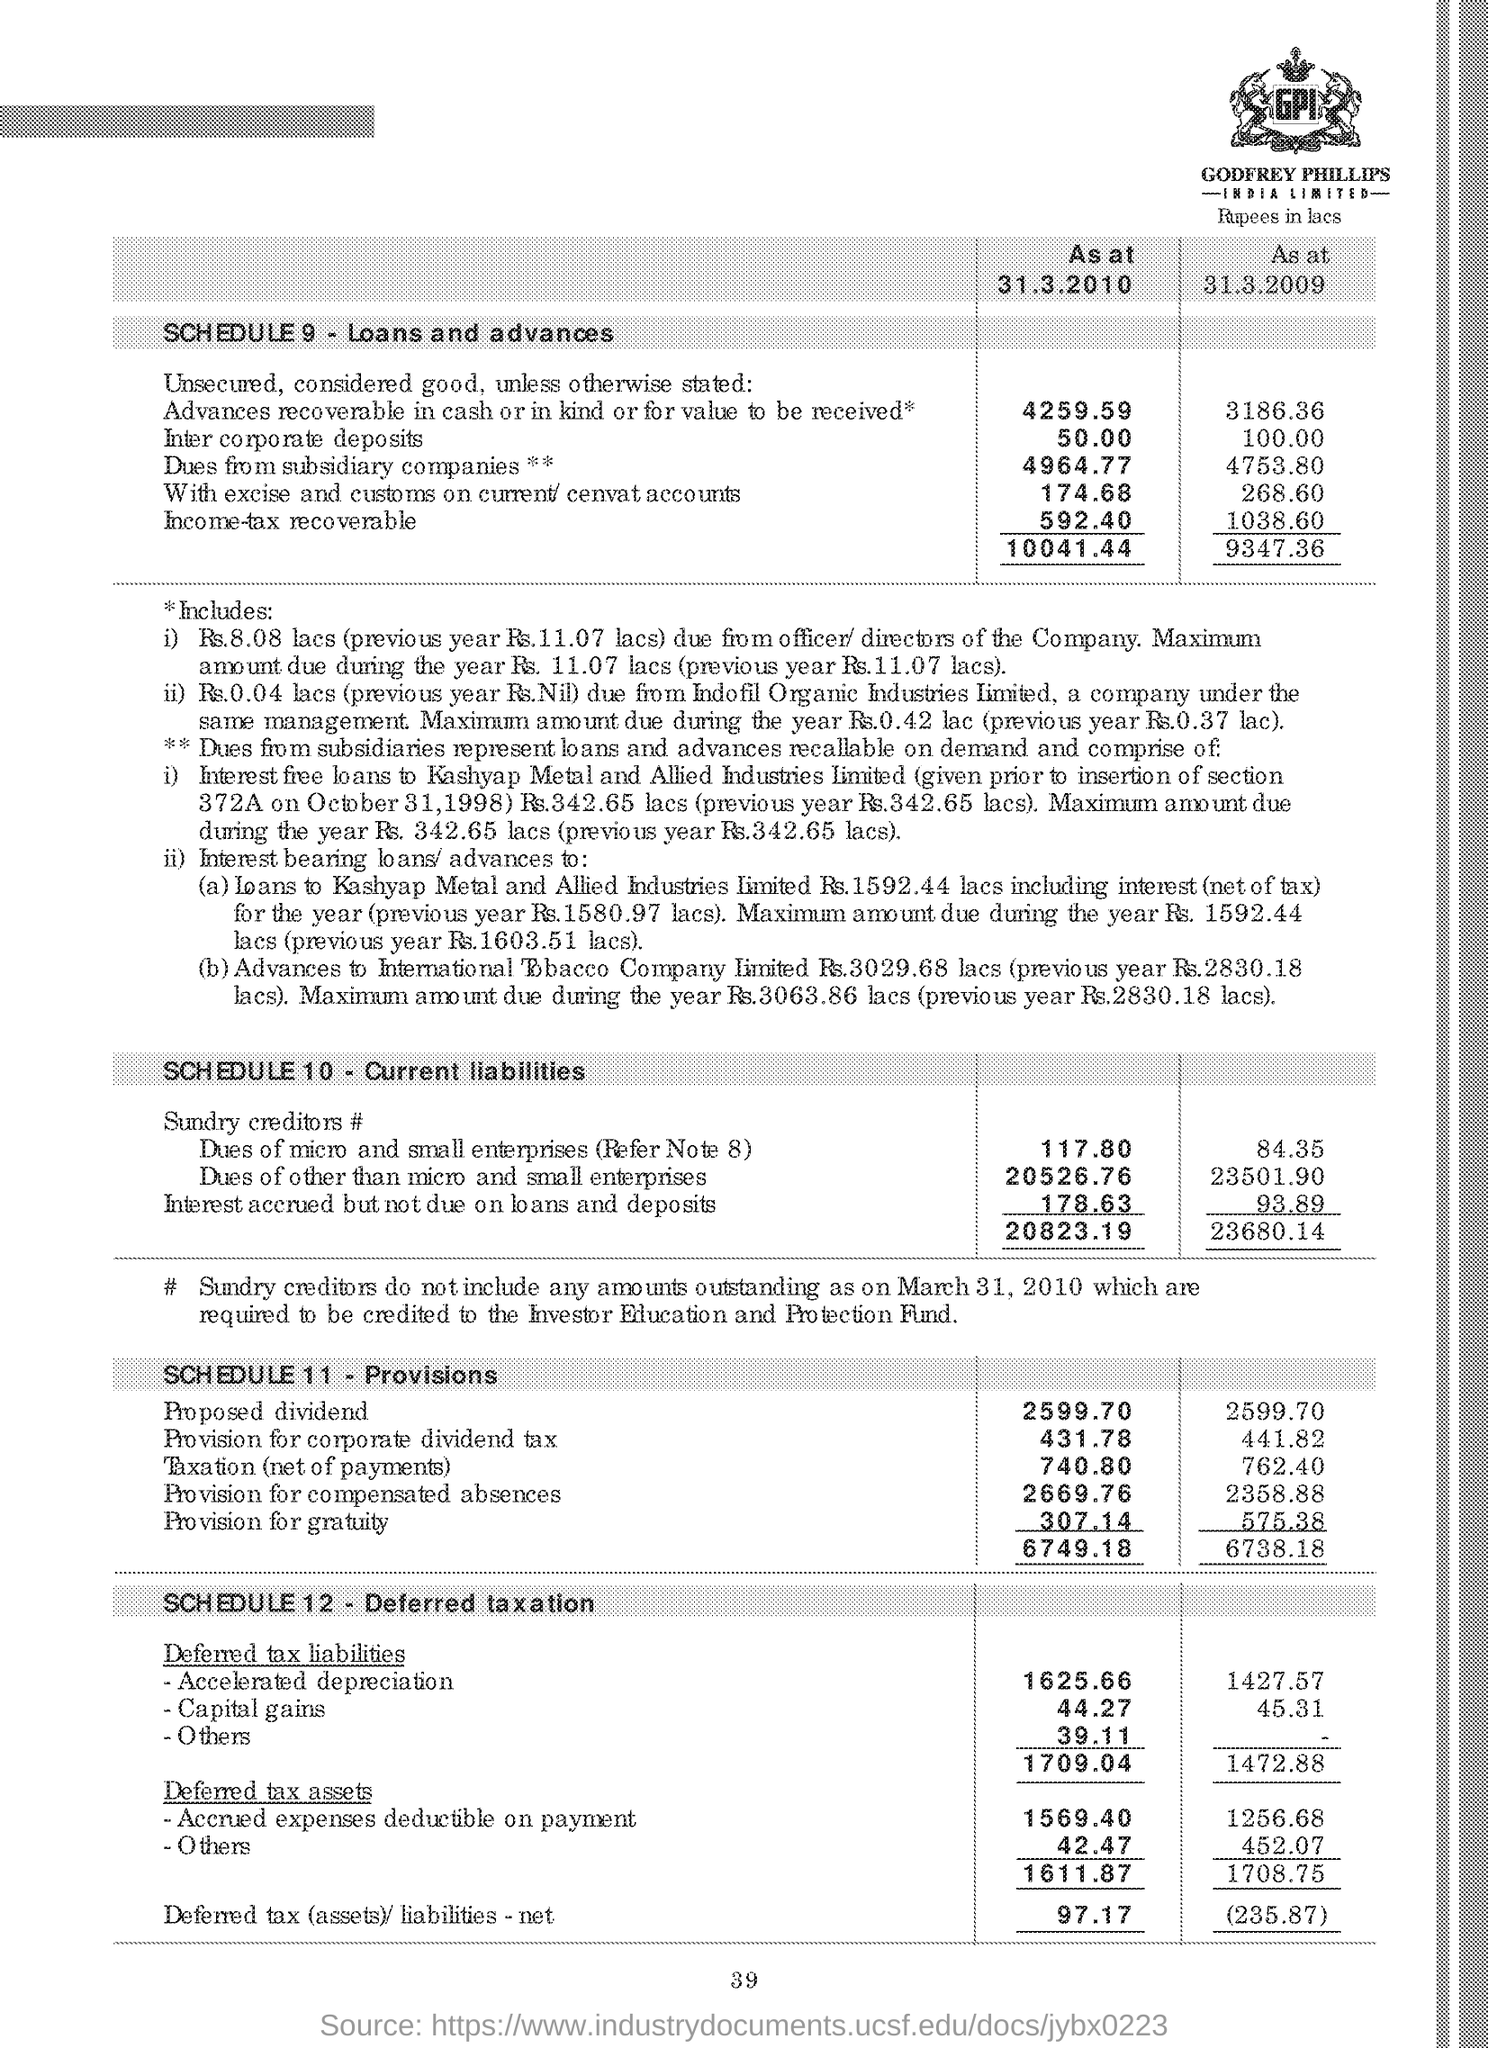What is the text written in the image?
Keep it short and to the point. GPI. 